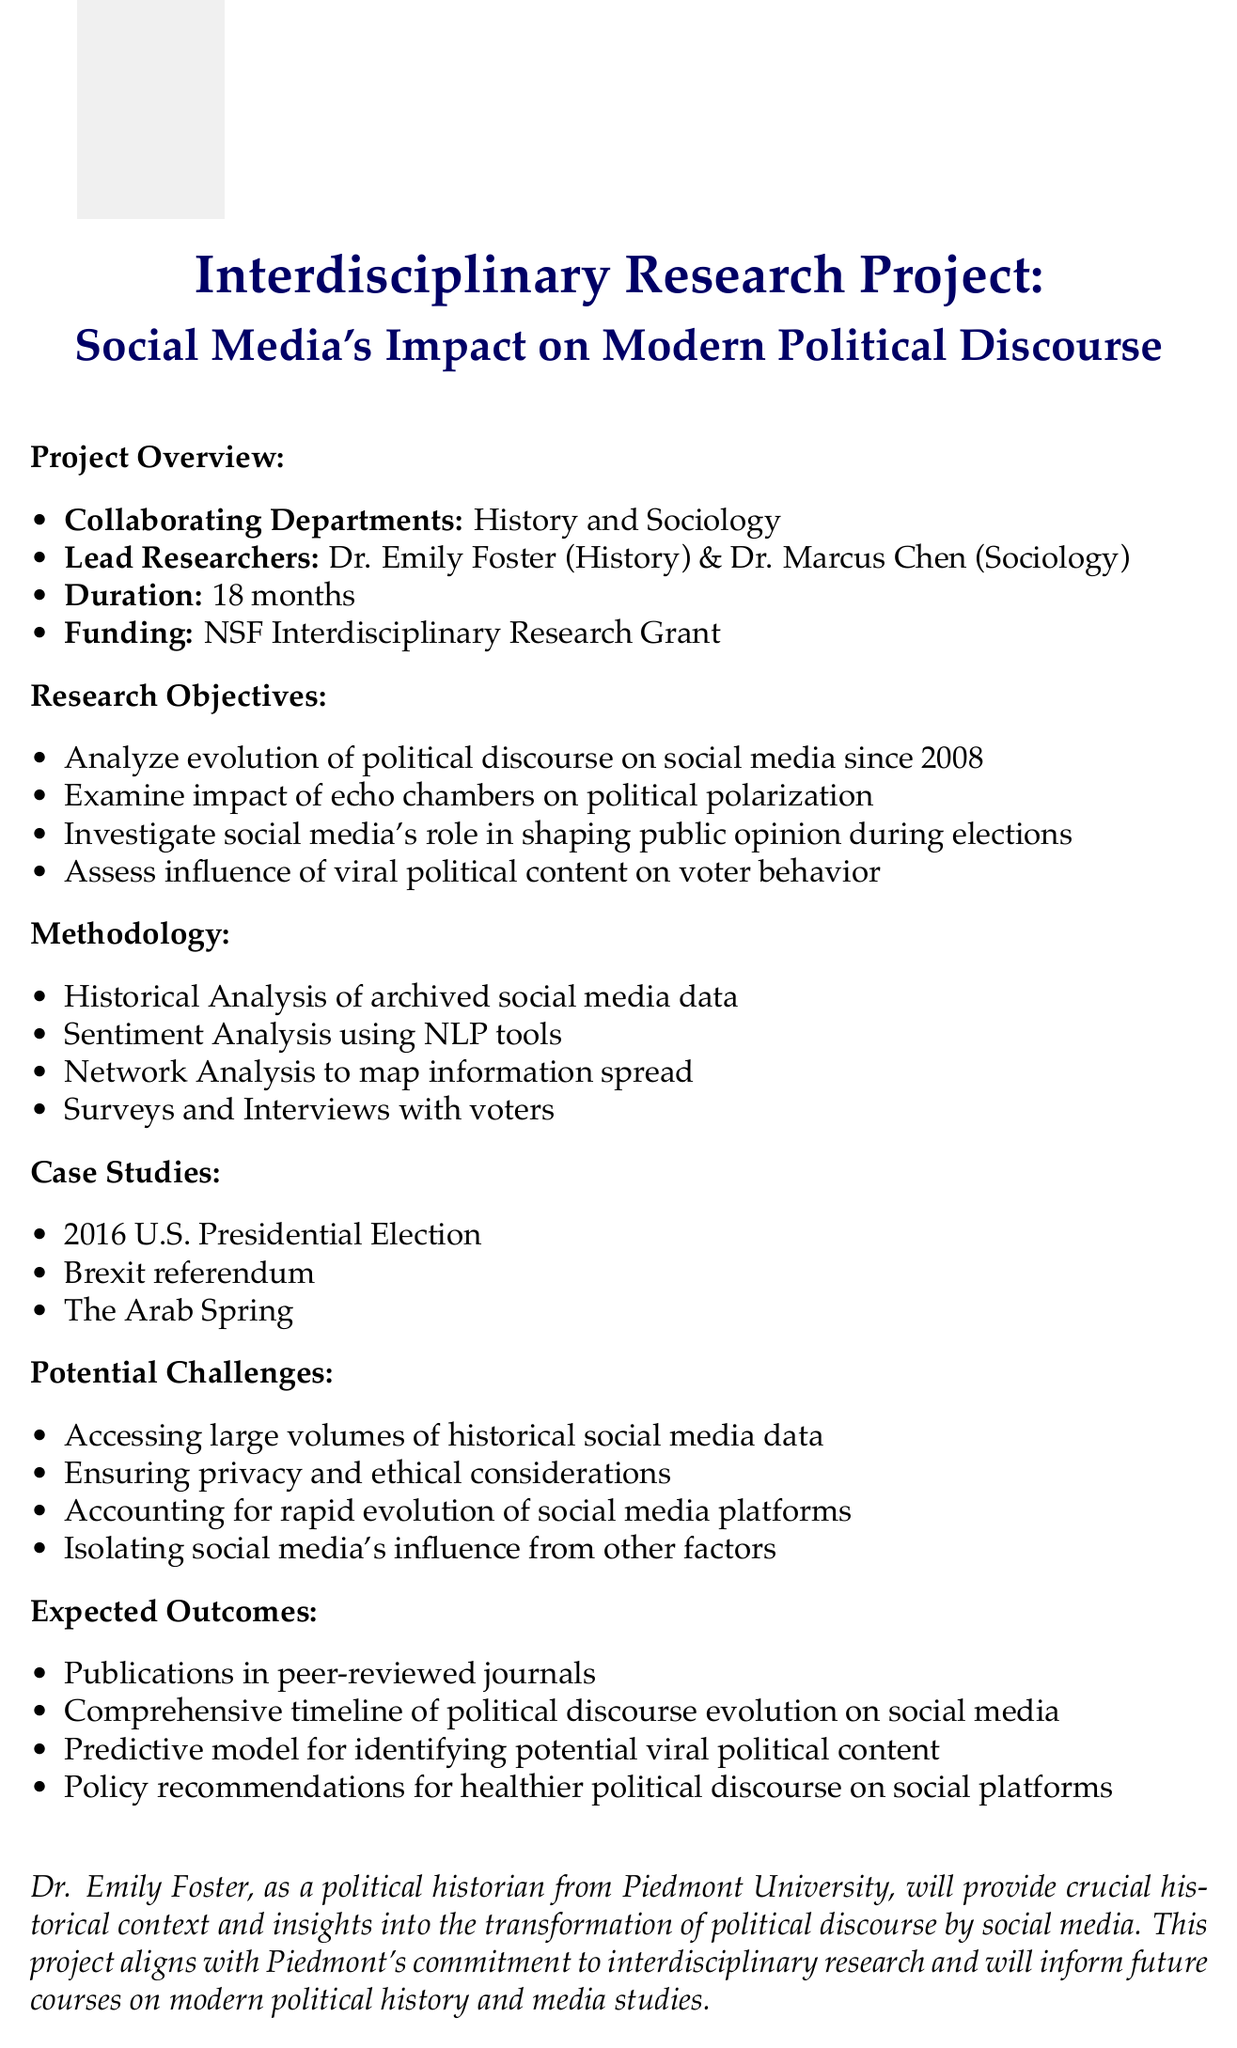What are the collaborating departments? The document specifies that the collaborative effort is between the History Department and the Sociology Department.
Answer: History and Sociology Who is the lead researcher from the Sociology Department? The memo mentions Dr. Marcus Chen as the lead researcher from the Sociology Department.
Answer: Dr. Marcus Chen What is the funding source for the research project? The project is funded by the National Science Foundation (NSF) Interdisciplinary Research Grant, as indicated in the document.
Answer: National Science Foundation (NSF) Interdisciplinary Research Grant How long is the project duration? The document states that the project's duration is 18 months.
Answer: 18 months What is one of the research objectives? The memo lists multiple objectives, one being to investigate the role of social media in shaping public opinion during recent election cycles.
Answer: Investigate the role of social media in shaping public opinion during recent election cycles What methodology involves analyzing archived social media data? According to the document, the methodology that involves analyzing archived social media data is called Historical Analysis.
Answer: Historical Analysis What is one of the potential challenges mentioned? The memo discusses accessing large volumes of historical social media data as a potential challenge.
Answer: Accessing large volumes of historical social media data What type of outcomes are expected from this research? Expected outcomes include the publication of research findings in peer-reviewed journals.
Answer: Publications in peer-reviewed journals How does Dr. Foster's expertise relate to the project? Dr. Foster's historical perspective provides insights into the historical context of political discourse affected by social media.
Answer: Historical context of political discourse 